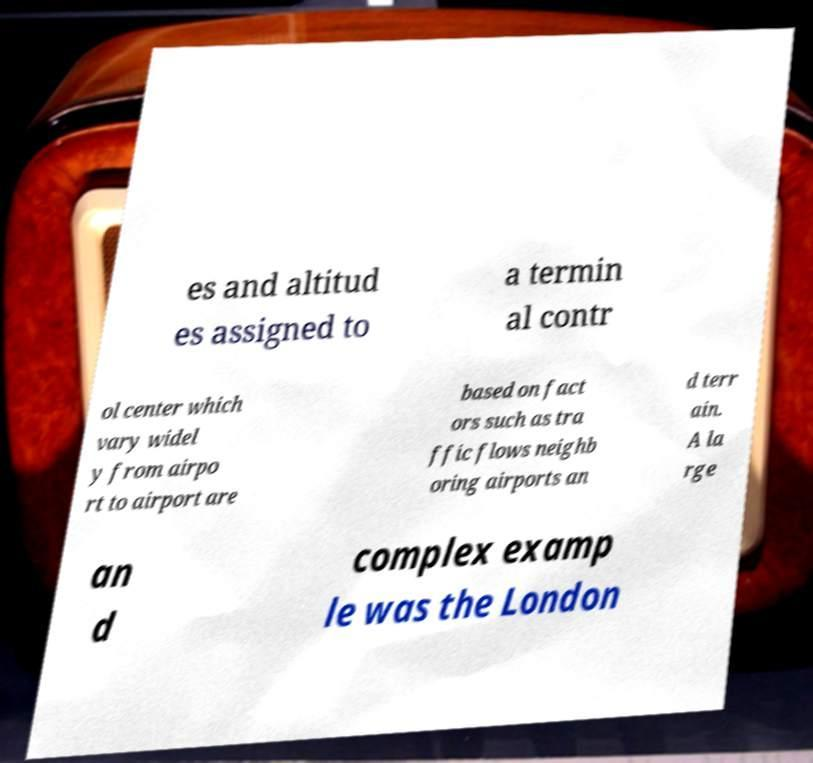I need the written content from this picture converted into text. Can you do that? es and altitud es assigned to a termin al contr ol center which vary widel y from airpo rt to airport are based on fact ors such as tra ffic flows neighb oring airports an d terr ain. A la rge an d complex examp le was the London 